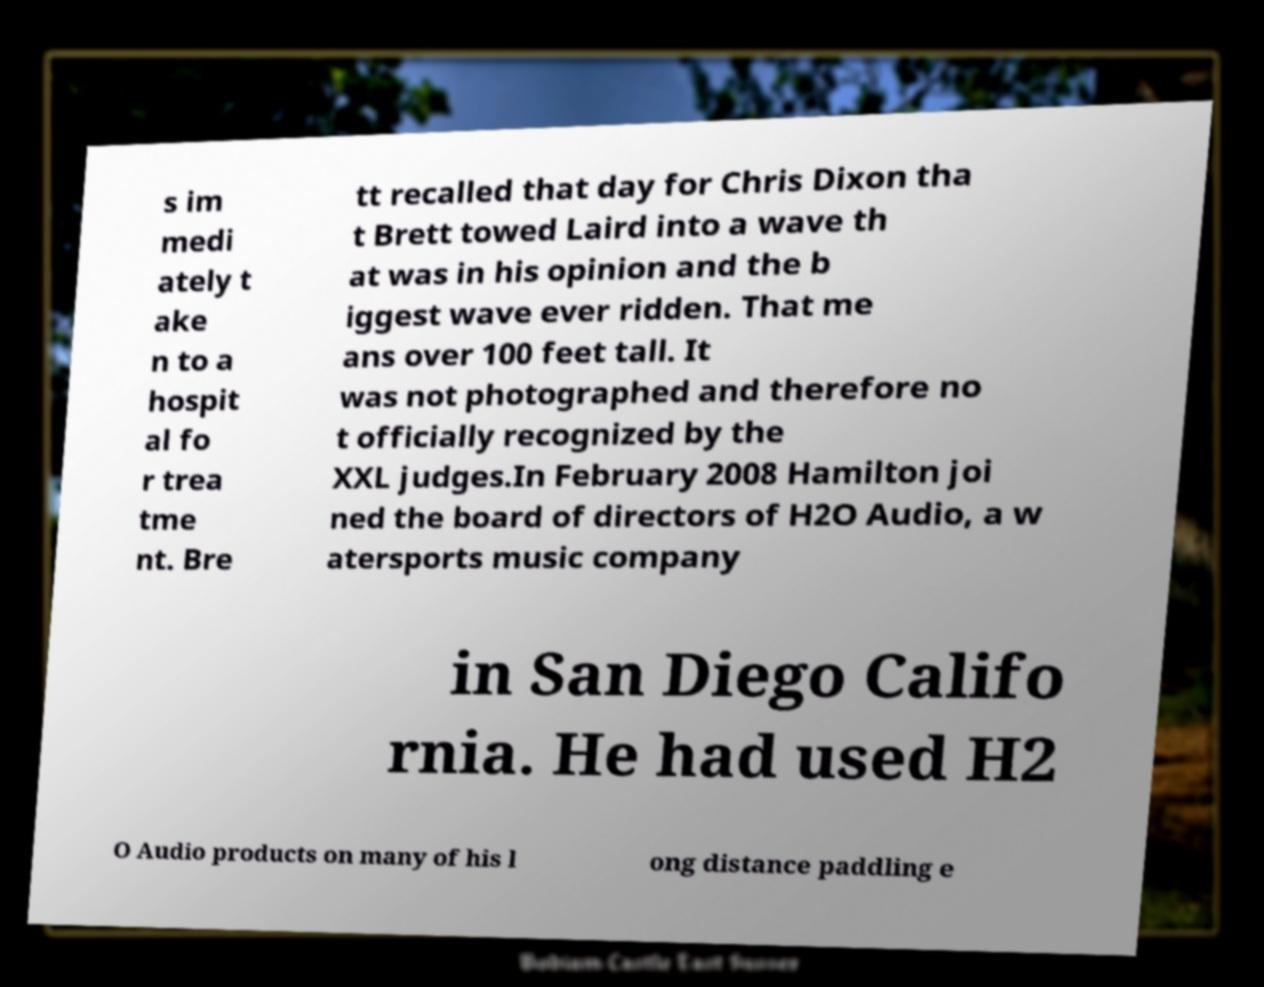Please identify and transcribe the text found in this image. s im medi ately t ake n to a hospit al fo r trea tme nt. Bre tt recalled that day for Chris Dixon tha t Brett towed Laird into a wave th at was in his opinion and the b iggest wave ever ridden. That me ans over 100 feet tall. It was not photographed and therefore no t officially recognized by the XXL judges.In February 2008 Hamilton joi ned the board of directors of H2O Audio, a w atersports music company in San Diego Califo rnia. He had used H2 O Audio products on many of his l ong distance paddling e 